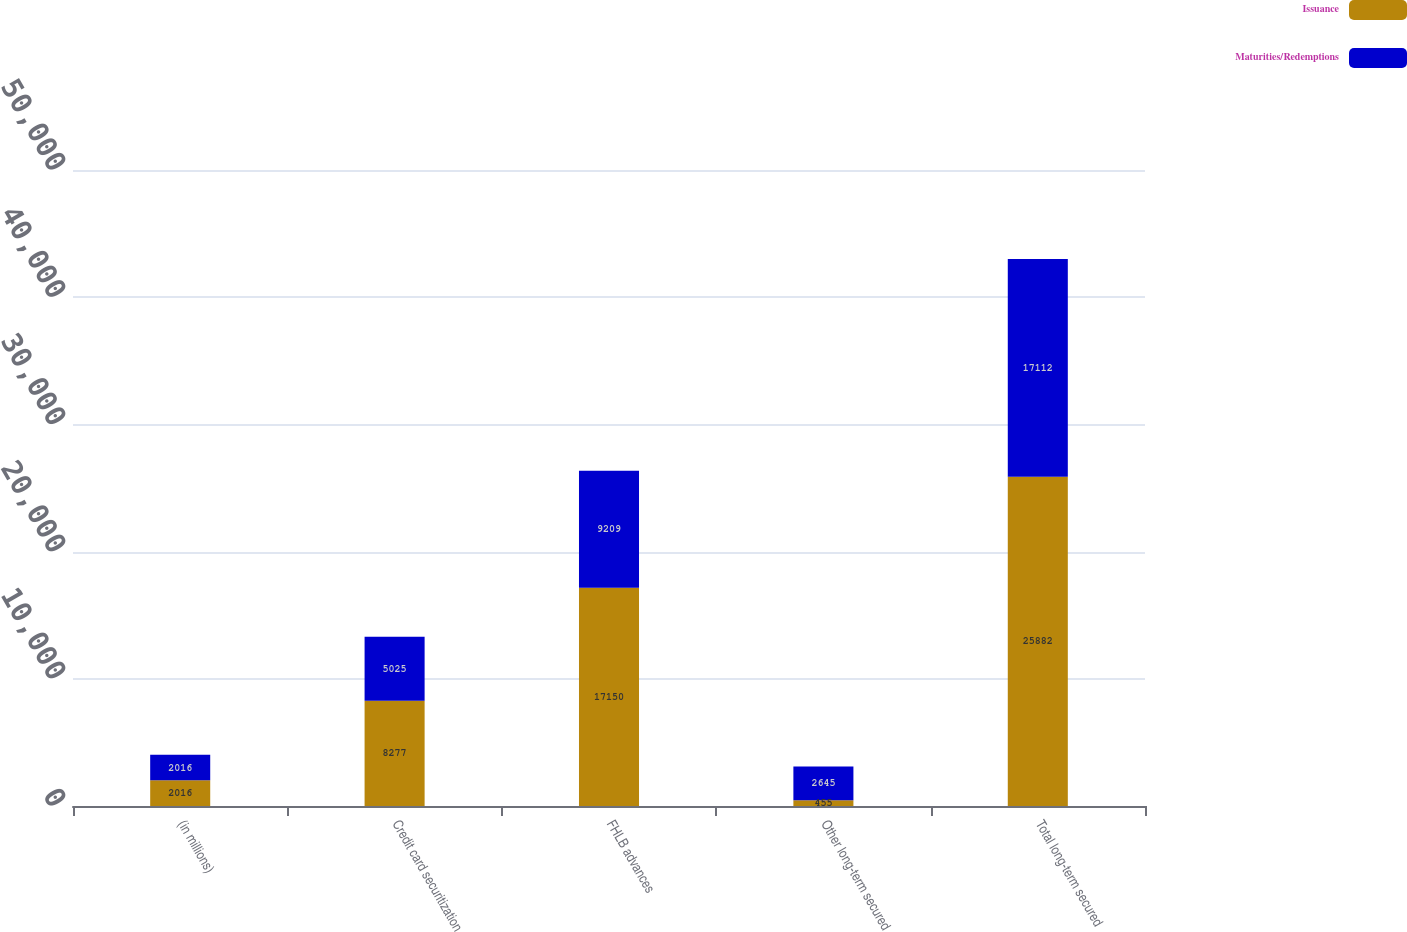Convert chart to OTSL. <chart><loc_0><loc_0><loc_500><loc_500><stacked_bar_chart><ecel><fcel>(in millions)<fcel>Credit card securitization<fcel>FHLB advances<fcel>Other long-term secured<fcel>Total long-term secured<nl><fcel>Issuance<fcel>2016<fcel>8277<fcel>17150<fcel>455<fcel>25882<nl><fcel>Maturities/Redemptions<fcel>2016<fcel>5025<fcel>9209<fcel>2645<fcel>17112<nl></chart> 